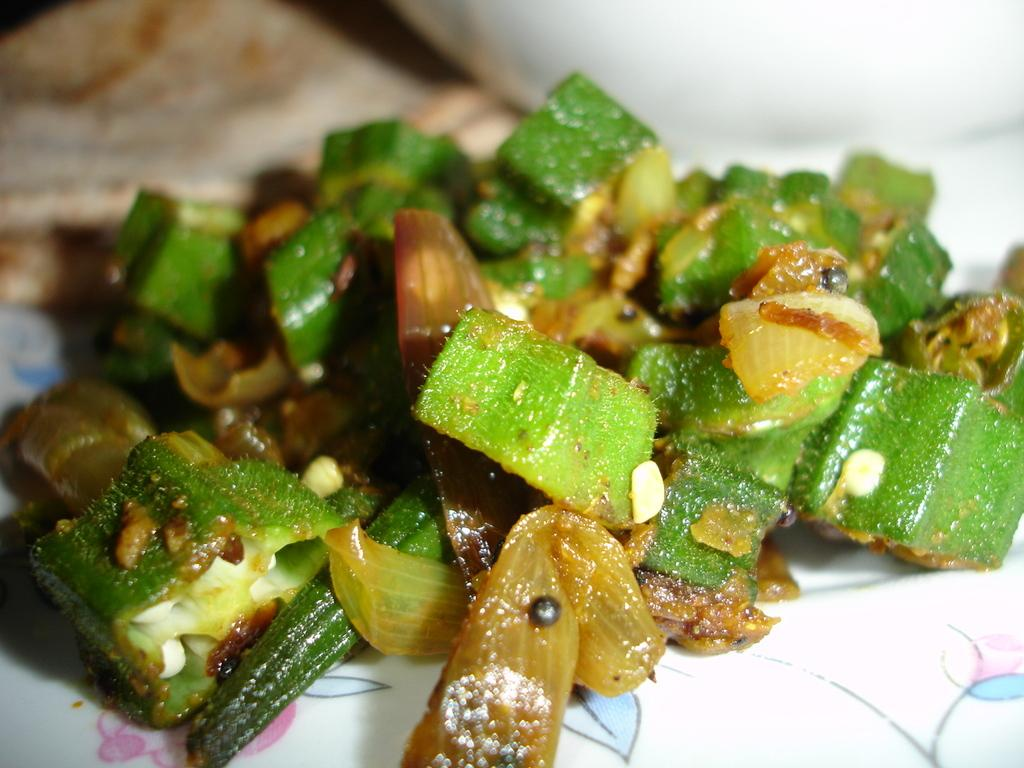What is on the white plate in the image? There is curry on the plate. What are some of the ingredients in the curry? The curry contains ladies finger pieces, onion pieces, and mustard seeds. What type of wire is used to hold the plate in the image? There is no wire present in the image; the plate is not being held up by any visible support. 